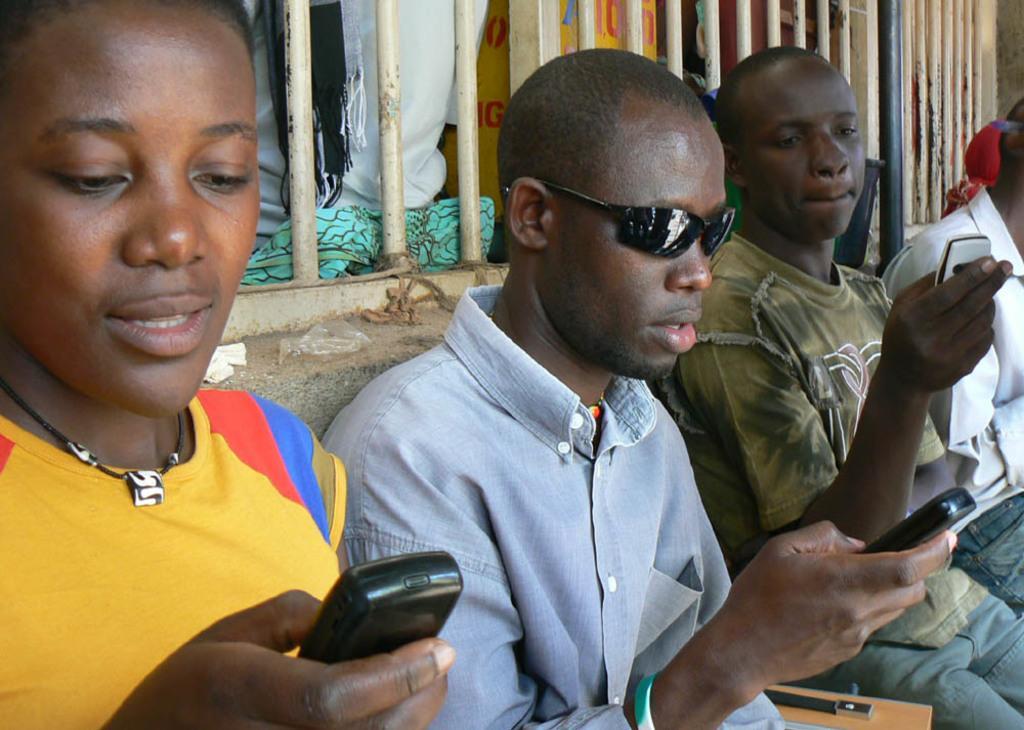Describe this image in one or two sentences. In this picture there is a man who is wearing goggle and shirt. He is sitting on the chair and holding a mobile phone. On the left there is another man who is wearing a locket and yellow t-shirt, he is looking on the mobile phone. On the right there are two persons sitting near to the window. At the top we can see pillar and pipe. Through the window we can see a man who is standing near to the wall. 